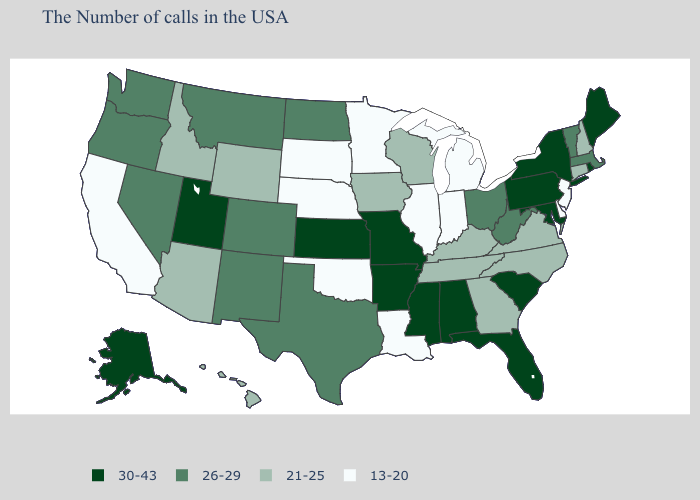What is the value of Washington?
Be succinct. 26-29. Among the states that border Illinois , does Kentucky have the lowest value?
Concise answer only. No. Name the states that have a value in the range 30-43?
Keep it brief. Maine, Rhode Island, New York, Maryland, Pennsylvania, South Carolina, Florida, Alabama, Mississippi, Missouri, Arkansas, Kansas, Utah, Alaska. What is the value of Wisconsin?
Quick response, please. 21-25. What is the value of Massachusetts?
Give a very brief answer. 26-29. Does the map have missing data?
Write a very short answer. No. Does Iowa have the lowest value in the USA?
Quick response, please. No. Name the states that have a value in the range 13-20?
Answer briefly. New Jersey, Delaware, Michigan, Indiana, Illinois, Louisiana, Minnesota, Nebraska, Oklahoma, South Dakota, California. What is the value of Arkansas?
Quick response, please. 30-43. How many symbols are there in the legend?
Short answer required. 4. Name the states that have a value in the range 13-20?
Write a very short answer. New Jersey, Delaware, Michigan, Indiana, Illinois, Louisiana, Minnesota, Nebraska, Oklahoma, South Dakota, California. Is the legend a continuous bar?
Answer briefly. No. Name the states that have a value in the range 30-43?
Short answer required. Maine, Rhode Island, New York, Maryland, Pennsylvania, South Carolina, Florida, Alabama, Mississippi, Missouri, Arkansas, Kansas, Utah, Alaska. Name the states that have a value in the range 26-29?
Quick response, please. Massachusetts, Vermont, West Virginia, Ohio, Texas, North Dakota, Colorado, New Mexico, Montana, Nevada, Washington, Oregon. Name the states that have a value in the range 30-43?
Write a very short answer. Maine, Rhode Island, New York, Maryland, Pennsylvania, South Carolina, Florida, Alabama, Mississippi, Missouri, Arkansas, Kansas, Utah, Alaska. 